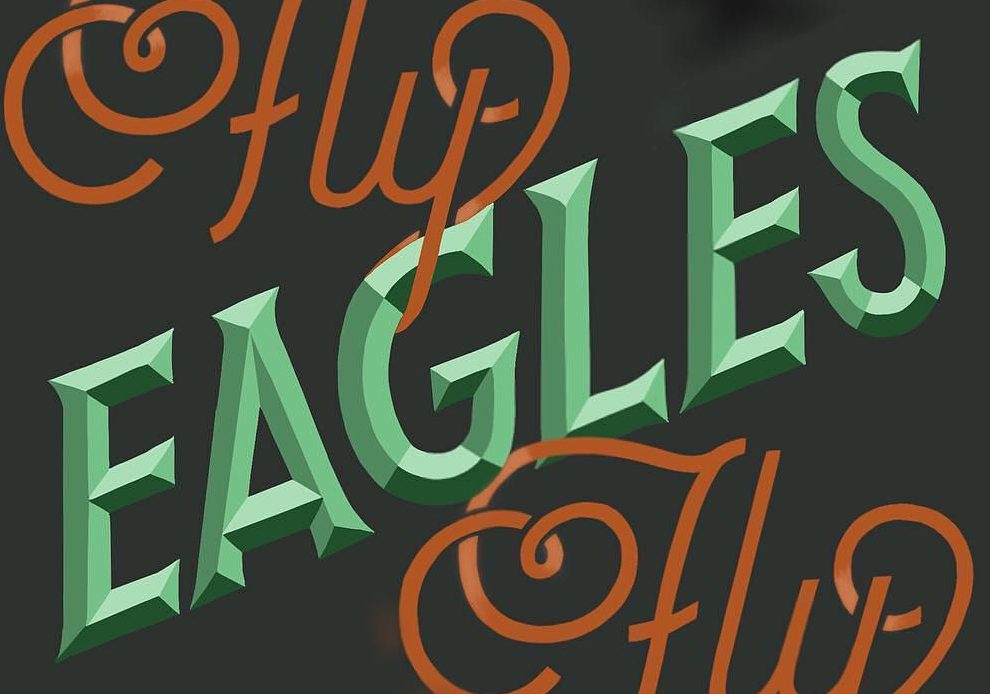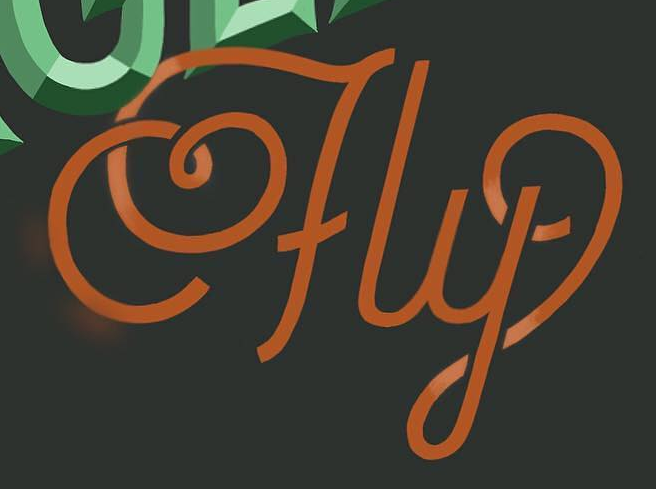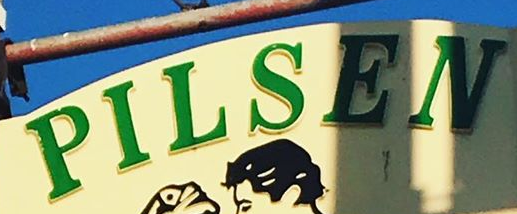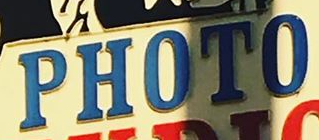What text appears in these images from left to right, separated by a semicolon? EAGLES; fly; PILSEN; PHOTO 